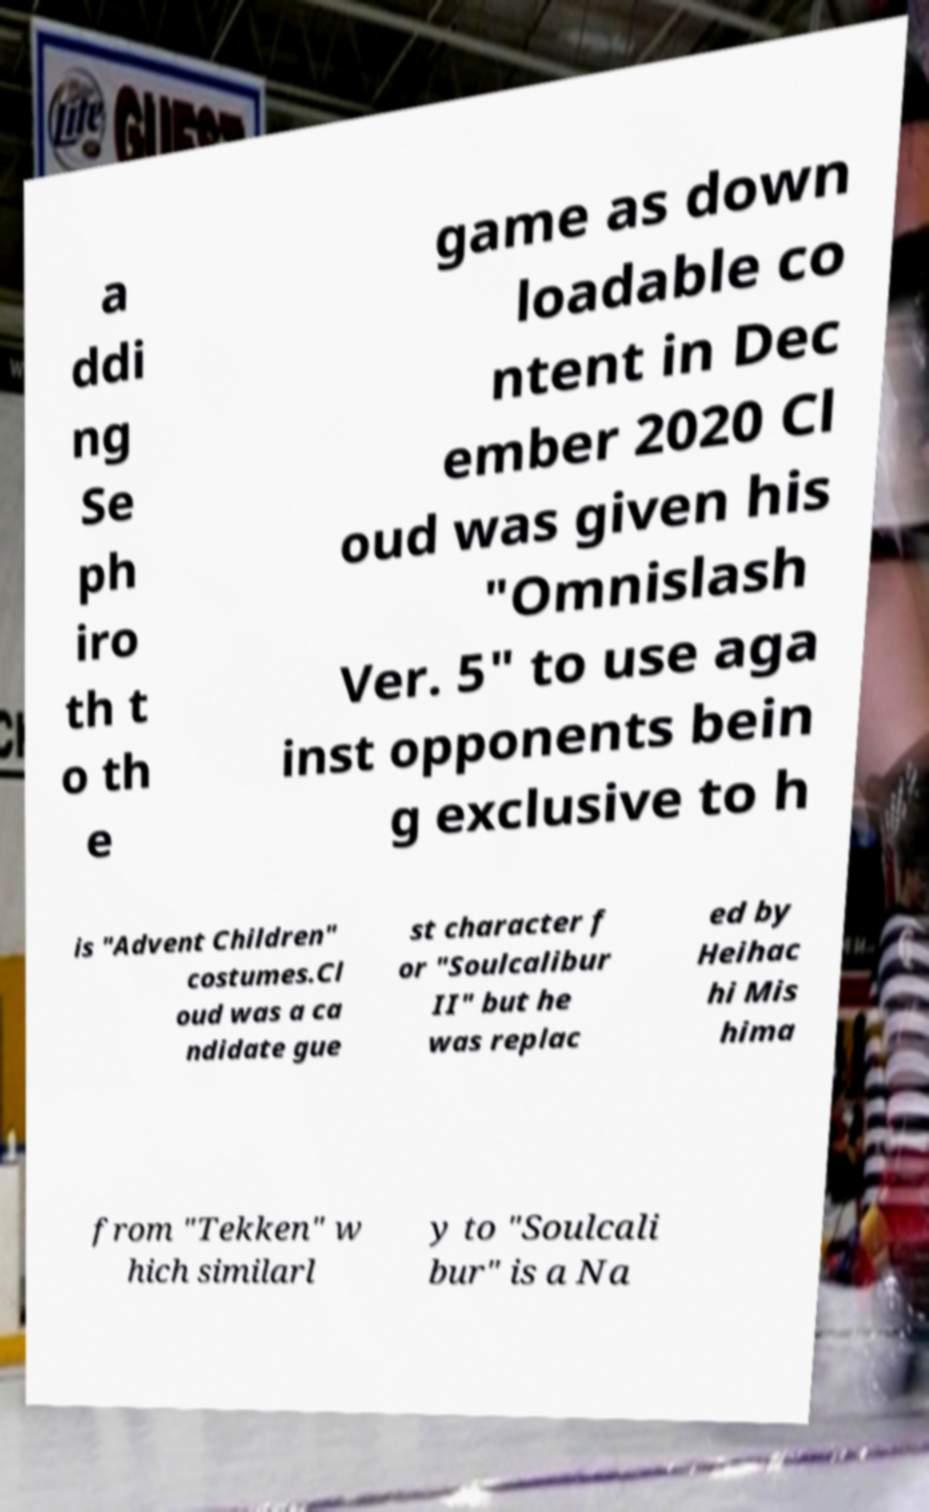I need the written content from this picture converted into text. Can you do that? a ddi ng Se ph iro th t o th e game as down loadable co ntent in Dec ember 2020 Cl oud was given his "Omnislash Ver. 5" to use aga inst opponents bein g exclusive to h is "Advent Children" costumes.Cl oud was a ca ndidate gue st character f or "Soulcalibur II" but he was replac ed by Heihac hi Mis hima from "Tekken" w hich similarl y to "Soulcali bur" is a Na 